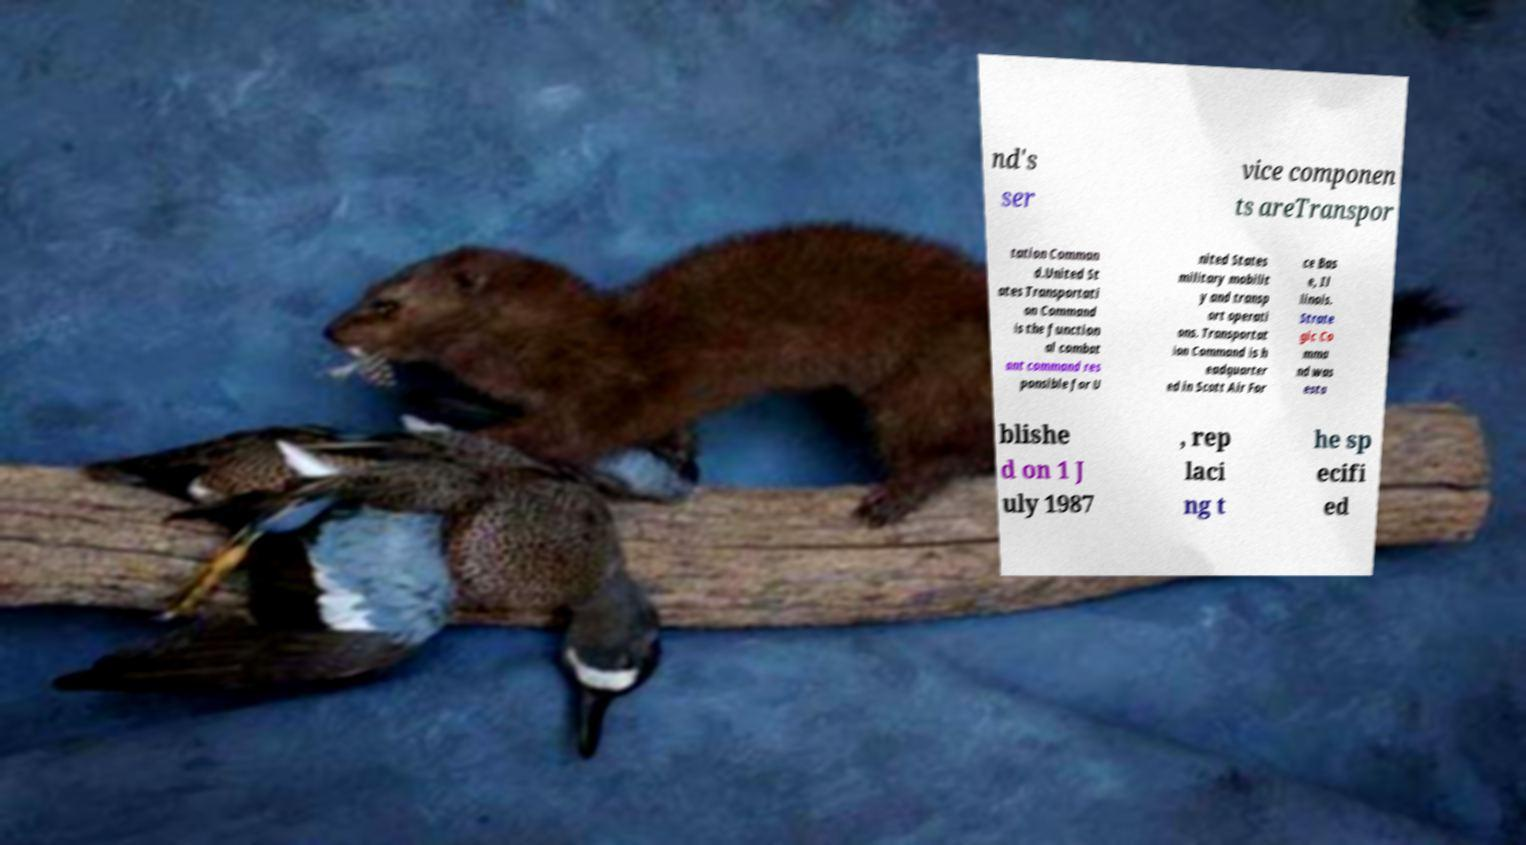Could you extract and type out the text from this image? nd's ser vice componen ts areTranspor tation Comman d.United St ates Transportati on Command is the function al combat ant command res ponsible for U nited States military mobilit y and transp ort operati ons. Transportat ion Command is h eadquarter ed in Scott Air For ce Bas e, Il linois. Strate gic Co mma nd was esta blishe d on 1 J uly 1987 , rep laci ng t he sp ecifi ed 